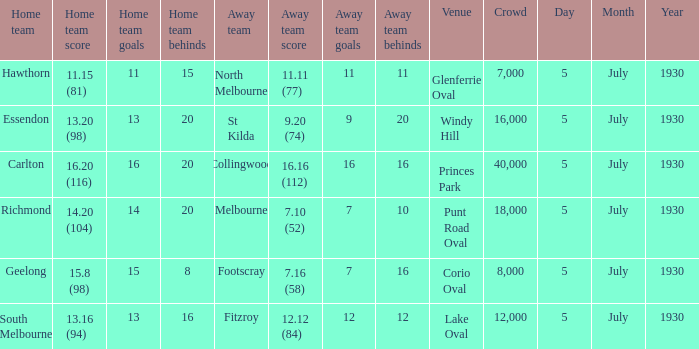Who is the guest team at corio oval? Footscray. 